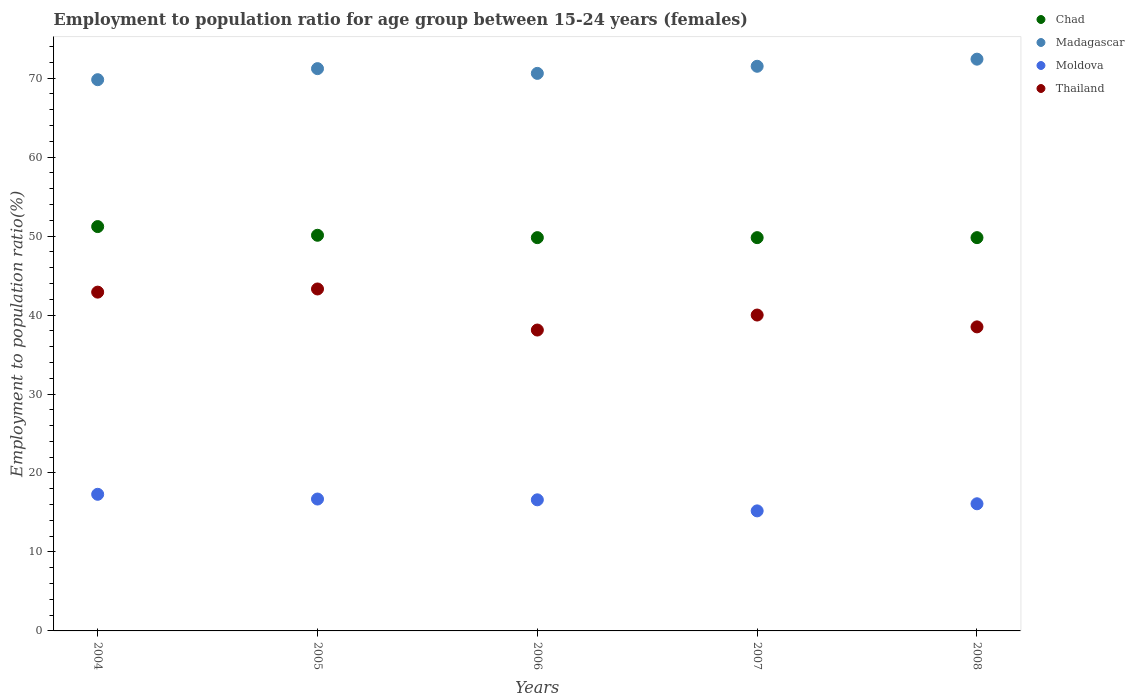How many different coloured dotlines are there?
Give a very brief answer. 4. Is the number of dotlines equal to the number of legend labels?
Offer a very short reply. Yes. What is the employment to population ratio in Thailand in 2006?
Your response must be concise. 38.1. Across all years, what is the maximum employment to population ratio in Madagascar?
Make the answer very short. 72.4. Across all years, what is the minimum employment to population ratio in Chad?
Provide a short and direct response. 49.8. In which year was the employment to population ratio in Moldova maximum?
Offer a terse response. 2004. What is the total employment to population ratio in Thailand in the graph?
Provide a succinct answer. 202.8. What is the difference between the employment to population ratio in Chad in 2005 and that in 2007?
Provide a succinct answer. 0.3. What is the difference between the employment to population ratio in Thailand in 2004 and the employment to population ratio in Chad in 2005?
Offer a very short reply. -7.2. What is the average employment to population ratio in Chad per year?
Your answer should be compact. 50.14. In the year 2004, what is the difference between the employment to population ratio in Chad and employment to population ratio in Moldova?
Your response must be concise. 33.9. What is the ratio of the employment to population ratio in Chad in 2006 to that in 2007?
Keep it short and to the point. 1. Is the employment to population ratio in Chad in 2005 less than that in 2007?
Your answer should be compact. No. What is the difference between the highest and the second highest employment to population ratio in Madagascar?
Keep it short and to the point. 0.9. What is the difference between the highest and the lowest employment to population ratio in Thailand?
Keep it short and to the point. 5.2. Is the sum of the employment to population ratio in Thailand in 2004 and 2007 greater than the maximum employment to population ratio in Moldova across all years?
Keep it short and to the point. Yes. Is the employment to population ratio in Chad strictly less than the employment to population ratio in Moldova over the years?
Ensure brevity in your answer.  No. How many years are there in the graph?
Give a very brief answer. 5. Are the values on the major ticks of Y-axis written in scientific E-notation?
Provide a short and direct response. No. Does the graph contain any zero values?
Make the answer very short. No. Does the graph contain grids?
Provide a succinct answer. No. Where does the legend appear in the graph?
Your answer should be compact. Top right. What is the title of the graph?
Your answer should be compact. Employment to population ratio for age group between 15-24 years (females). What is the Employment to population ratio(%) of Chad in 2004?
Keep it short and to the point. 51.2. What is the Employment to population ratio(%) in Madagascar in 2004?
Provide a succinct answer. 69.8. What is the Employment to population ratio(%) in Moldova in 2004?
Provide a succinct answer. 17.3. What is the Employment to population ratio(%) in Thailand in 2004?
Your answer should be compact. 42.9. What is the Employment to population ratio(%) in Chad in 2005?
Ensure brevity in your answer.  50.1. What is the Employment to population ratio(%) of Madagascar in 2005?
Provide a succinct answer. 71.2. What is the Employment to population ratio(%) of Moldova in 2005?
Provide a succinct answer. 16.7. What is the Employment to population ratio(%) in Thailand in 2005?
Give a very brief answer. 43.3. What is the Employment to population ratio(%) in Chad in 2006?
Give a very brief answer. 49.8. What is the Employment to population ratio(%) in Madagascar in 2006?
Give a very brief answer. 70.6. What is the Employment to population ratio(%) in Moldova in 2006?
Give a very brief answer. 16.6. What is the Employment to population ratio(%) in Thailand in 2006?
Offer a very short reply. 38.1. What is the Employment to population ratio(%) in Chad in 2007?
Ensure brevity in your answer.  49.8. What is the Employment to population ratio(%) in Madagascar in 2007?
Your answer should be compact. 71.5. What is the Employment to population ratio(%) of Moldova in 2007?
Give a very brief answer. 15.2. What is the Employment to population ratio(%) in Thailand in 2007?
Give a very brief answer. 40. What is the Employment to population ratio(%) of Chad in 2008?
Offer a terse response. 49.8. What is the Employment to population ratio(%) of Madagascar in 2008?
Provide a short and direct response. 72.4. What is the Employment to population ratio(%) in Moldova in 2008?
Make the answer very short. 16.1. What is the Employment to population ratio(%) of Thailand in 2008?
Offer a terse response. 38.5. Across all years, what is the maximum Employment to population ratio(%) of Chad?
Offer a terse response. 51.2. Across all years, what is the maximum Employment to population ratio(%) in Madagascar?
Offer a terse response. 72.4. Across all years, what is the maximum Employment to population ratio(%) of Moldova?
Provide a succinct answer. 17.3. Across all years, what is the maximum Employment to population ratio(%) in Thailand?
Ensure brevity in your answer.  43.3. Across all years, what is the minimum Employment to population ratio(%) of Chad?
Your response must be concise. 49.8. Across all years, what is the minimum Employment to population ratio(%) of Madagascar?
Your response must be concise. 69.8. Across all years, what is the minimum Employment to population ratio(%) in Moldova?
Keep it short and to the point. 15.2. Across all years, what is the minimum Employment to population ratio(%) of Thailand?
Keep it short and to the point. 38.1. What is the total Employment to population ratio(%) of Chad in the graph?
Give a very brief answer. 250.7. What is the total Employment to population ratio(%) of Madagascar in the graph?
Keep it short and to the point. 355.5. What is the total Employment to population ratio(%) in Moldova in the graph?
Your answer should be compact. 81.9. What is the total Employment to population ratio(%) of Thailand in the graph?
Your response must be concise. 202.8. What is the difference between the Employment to population ratio(%) of Chad in 2004 and that in 2005?
Offer a terse response. 1.1. What is the difference between the Employment to population ratio(%) of Madagascar in 2004 and that in 2005?
Make the answer very short. -1.4. What is the difference between the Employment to population ratio(%) in Moldova in 2004 and that in 2005?
Your answer should be compact. 0.6. What is the difference between the Employment to population ratio(%) in Thailand in 2004 and that in 2005?
Your answer should be very brief. -0.4. What is the difference between the Employment to population ratio(%) in Chad in 2004 and that in 2006?
Give a very brief answer. 1.4. What is the difference between the Employment to population ratio(%) of Madagascar in 2004 and that in 2006?
Keep it short and to the point. -0.8. What is the difference between the Employment to population ratio(%) in Moldova in 2004 and that in 2006?
Your answer should be very brief. 0.7. What is the difference between the Employment to population ratio(%) in Chad in 2004 and that in 2007?
Give a very brief answer. 1.4. What is the difference between the Employment to population ratio(%) of Moldova in 2004 and that in 2007?
Offer a terse response. 2.1. What is the difference between the Employment to population ratio(%) of Thailand in 2004 and that in 2007?
Offer a very short reply. 2.9. What is the difference between the Employment to population ratio(%) of Chad in 2004 and that in 2008?
Provide a succinct answer. 1.4. What is the difference between the Employment to population ratio(%) of Thailand in 2004 and that in 2008?
Make the answer very short. 4.4. What is the difference between the Employment to population ratio(%) in Madagascar in 2005 and that in 2006?
Make the answer very short. 0.6. What is the difference between the Employment to population ratio(%) in Thailand in 2005 and that in 2006?
Make the answer very short. 5.2. What is the difference between the Employment to population ratio(%) in Moldova in 2005 and that in 2007?
Your response must be concise. 1.5. What is the difference between the Employment to population ratio(%) of Thailand in 2005 and that in 2007?
Provide a short and direct response. 3.3. What is the difference between the Employment to population ratio(%) in Chad in 2005 and that in 2008?
Ensure brevity in your answer.  0.3. What is the difference between the Employment to population ratio(%) of Moldova in 2005 and that in 2008?
Make the answer very short. 0.6. What is the difference between the Employment to population ratio(%) in Chad in 2006 and that in 2007?
Give a very brief answer. 0. What is the difference between the Employment to population ratio(%) in Madagascar in 2006 and that in 2007?
Your answer should be very brief. -0.9. What is the difference between the Employment to population ratio(%) in Thailand in 2006 and that in 2007?
Provide a succinct answer. -1.9. What is the difference between the Employment to population ratio(%) of Chad in 2006 and that in 2008?
Provide a succinct answer. 0. What is the difference between the Employment to population ratio(%) of Madagascar in 2006 and that in 2008?
Offer a very short reply. -1.8. What is the difference between the Employment to population ratio(%) in Moldova in 2006 and that in 2008?
Offer a terse response. 0.5. What is the difference between the Employment to population ratio(%) in Chad in 2007 and that in 2008?
Give a very brief answer. 0. What is the difference between the Employment to population ratio(%) in Madagascar in 2007 and that in 2008?
Your answer should be very brief. -0.9. What is the difference between the Employment to population ratio(%) of Moldova in 2007 and that in 2008?
Make the answer very short. -0.9. What is the difference between the Employment to population ratio(%) in Chad in 2004 and the Employment to population ratio(%) in Moldova in 2005?
Keep it short and to the point. 34.5. What is the difference between the Employment to population ratio(%) of Madagascar in 2004 and the Employment to population ratio(%) of Moldova in 2005?
Your response must be concise. 53.1. What is the difference between the Employment to population ratio(%) in Moldova in 2004 and the Employment to population ratio(%) in Thailand in 2005?
Your answer should be very brief. -26. What is the difference between the Employment to population ratio(%) in Chad in 2004 and the Employment to population ratio(%) in Madagascar in 2006?
Keep it short and to the point. -19.4. What is the difference between the Employment to population ratio(%) in Chad in 2004 and the Employment to population ratio(%) in Moldova in 2006?
Offer a terse response. 34.6. What is the difference between the Employment to population ratio(%) of Madagascar in 2004 and the Employment to population ratio(%) of Moldova in 2006?
Offer a terse response. 53.2. What is the difference between the Employment to population ratio(%) of Madagascar in 2004 and the Employment to population ratio(%) of Thailand in 2006?
Keep it short and to the point. 31.7. What is the difference between the Employment to population ratio(%) of Moldova in 2004 and the Employment to population ratio(%) of Thailand in 2006?
Keep it short and to the point. -20.8. What is the difference between the Employment to population ratio(%) in Chad in 2004 and the Employment to population ratio(%) in Madagascar in 2007?
Offer a terse response. -20.3. What is the difference between the Employment to population ratio(%) of Chad in 2004 and the Employment to population ratio(%) of Moldova in 2007?
Make the answer very short. 36. What is the difference between the Employment to population ratio(%) of Chad in 2004 and the Employment to population ratio(%) of Thailand in 2007?
Offer a terse response. 11.2. What is the difference between the Employment to population ratio(%) of Madagascar in 2004 and the Employment to population ratio(%) of Moldova in 2007?
Ensure brevity in your answer.  54.6. What is the difference between the Employment to population ratio(%) of Madagascar in 2004 and the Employment to population ratio(%) of Thailand in 2007?
Offer a terse response. 29.8. What is the difference between the Employment to population ratio(%) in Moldova in 2004 and the Employment to population ratio(%) in Thailand in 2007?
Your answer should be very brief. -22.7. What is the difference between the Employment to population ratio(%) in Chad in 2004 and the Employment to population ratio(%) in Madagascar in 2008?
Your response must be concise. -21.2. What is the difference between the Employment to population ratio(%) of Chad in 2004 and the Employment to population ratio(%) of Moldova in 2008?
Give a very brief answer. 35.1. What is the difference between the Employment to population ratio(%) of Madagascar in 2004 and the Employment to population ratio(%) of Moldova in 2008?
Your answer should be compact. 53.7. What is the difference between the Employment to population ratio(%) of Madagascar in 2004 and the Employment to population ratio(%) of Thailand in 2008?
Make the answer very short. 31.3. What is the difference between the Employment to population ratio(%) in Moldova in 2004 and the Employment to population ratio(%) in Thailand in 2008?
Give a very brief answer. -21.2. What is the difference between the Employment to population ratio(%) in Chad in 2005 and the Employment to population ratio(%) in Madagascar in 2006?
Offer a terse response. -20.5. What is the difference between the Employment to population ratio(%) in Chad in 2005 and the Employment to population ratio(%) in Moldova in 2006?
Make the answer very short. 33.5. What is the difference between the Employment to population ratio(%) of Madagascar in 2005 and the Employment to population ratio(%) of Moldova in 2006?
Your response must be concise. 54.6. What is the difference between the Employment to population ratio(%) of Madagascar in 2005 and the Employment to population ratio(%) of Thailand in 2006?
Offer a very short reply. 33.1. What is the difference between the Employment to population ratio(%) in Moldova in 2005 and the Employment to population ratio(%) in Thailand in 2006?
Provide a succinct answer. -21.4. What is the difference between the Employment to population ratio(%) in Chad in 2005 and the Employment to population ratio(%) in Madagascar in 2007?
Offer a very short reply. -21.4. What is the difference between the Employment to population ratio(%) of Chad in 2005 and the Employment to population ratio(%) of Moldova in 2007?
Ensure brevity in your answer.  34.9. What is the difference between the Employment to population ratio(%) of Chad in 2005 and the Employment to population ratio(%) of Thailand in 2007?
Make the answer very short. 10.1. What is the difference between the Employment to population ratio(%) of Madagascar in 2005 and the Employment to population ratio(%) of Thailand in 2007?
Your answer should be compact. 31.2. What is the difference between the Employment to population ratio(%) in Moldova in 2005 and the Employment to population ratio(%) in Thailand in 2007?
Your answer should be compact. -23.3. What is the difference between the Employment to population ratio(%) of Chad in 2005 and the Employment to population ratio(%) of Madagascar in 2008?
Your answer should be very brief. -22.3. What is the difference between the Employment to population ratio(%) of Chad in 2005 and the Employment to population ratio(%) of Moldova in 2008?
Keep it short and to the point. 34. What is the difference between the Employment to population ratio(%) of Chad in 2005 and the Employment to population ratio(%) of Thailand in 2008?
Make the answer very short. 11.6. What is the difference between the Employment to population ratio(%) in Madagascar in 2005 and the Employment to population ratio(%) in Moldova in 2008?
Give a very brief answer. 55.1. What is the difference between the Employment to population ratio(%) in Madagascar in 2005 and the Employment to population ratio(%) in Thailand in 2008?
Make the answer very short. 32.7. What is the difference between the Employment to population ratio(%) in Moldova in 2005 and the Employment to population ratio(%) in Thailand in 2008?
Provide a short and direct response. -21.8. What is the difference between the Employment to population ratio(%) of Chad in 2006 and the Employment to population ratio(%) of Madagascar in 2007?
Ensure brevity in your answer.  -21.7. What is the difference between the Employment to population ratio(%) of Chad in 2006 and the Employment to population ratio(%) of Moldova in 2007?
Keep it short and to the point. 34.6. What is the difference between the Employment to population ratio(%) of Chad in 2006 and the Employment to population ratio(%) of Thailand in 2007?
Provide a short and direct response. 9.8. What is the difference between the Employment to population ratio(%) in Madagascar in 2006 and the Employment to population ratio(%) in Moldova in 2007?
Offer a terse response. 55.4. What is the difference between the Employment to population ratio(%) of Madagascar in 2006 and the Employment to population ratio(%) of Thailand in 2007?
Give a very brief answer. 30.6. What is the difference between the Employment to population ratio(%) in Moldova in 2006 and the Employment to population ratio(%) in Thailand in 2007?
Ensure brevity in your answer.  -23.4. What is the difference between the Employment to population ratio(%) of Chad in 2006 and the Employment to population ratio(%) of Madagascar in 2008?
Provide a short and direct response. -22.6. What is the difference between the Employment to population ratio(%) in Chad in 2006 and the Employment to population ratio(%) in Moldova in 2008?
Provide a short and direct response. 33.7. What is the difference between the Employment to population ratio(%) of Madagascar in 2006 and the Employment to population ratio(%) of Moldova in 2008?
Ensure brevity in your answer.  54.5. What is the difference between the Employment to population ratio(%) in Madagascar in 2006 and the Employment to population ratio(%) in Thailand in 2008?
Your answer should be compact. 32.1. What is the difference between the Employment to population ratio(%) of Moldova in 2006 and the Employment to population ratio(%) of Thailand in 2008?
Keep it short and to the point. -21.9. What is the difference between the Employment to population ratio(%) in Chad in 2007 and the Employment to population ratio(%) in Madagascar in 2008?
Offer a very short reply. -22.6. What is the difference between the Employment to population ratio(%) in Chad in 2007 and the Employment to population ratio(%) in Moldova in 2008?
Make the answer very short. 33.7. What is the difference between the Employment to population ratio(%) in Madagascar in 2007 and the Employment to population ratio(%) in Moldova in 2008?
Provide a succinct answer. 55.4. What is the difference between the Employment to population ratio(%) in Madagascar in 2007 and the Employment to population ratio(%) in Thailand in 2008?
Your answer should be very brief. 33. What is the difference between the Employment to population ratio(%) in Moldova in 2007 and the Employment to population ratio(%) in Thailand in 2008?
Make the answer very short. -23.3. What is the average Employment to population ratio(%) of Chad per year?
Give a very brief answer. 50.14. What is the average Employment to population ratio(%) of Madagascar per year?
Your response must be concise. 71.1. What is the average Employment to population ratio(%) of Moldova per year?
Your answer should be compact. 16.38. What is the average Employment to population ratio(%) in Thailand per year?
Your response must be concise. 40.56. In the year 2004, what is the difference between the Employment to population ratio(%) of Chad and Employment to population ratio(%) of Madagascar?
Your answer should be very brief. -18.6. In the year 2004, what is the difference between the Employment to population ratio(%) in Chad and Employment to population ratio(%) in Moldova?
Your response must be concise. 33.9. In the year 2004, what is the difference between the Employment to population ratio(%) in Chad and Employment to population ratio(%) in Thailand?
Your response must be concise. 8.3. In the year 2004, what is the difference between the Employment to population ratio(%) in Madagascar and Employment to population ratio(%) in Moldova?
Ensure brevity in your answer.  52.5. In the year 2004, what is the difference between the Employment to population ratio(%) in Madagascar and Employment to population ratio(%) in Thailand?
Give a very brief answer. 26.9. In the year 2004, what is the difference between the Employment to population ratio(%) in Moldova and Employment to population ratio(%) in Thailand?
Provide a succinct answer. -25.6. In the year 2005, what is the difference between the Employment to population ratio(%) in Chad and Employment to population ratio(%) in Madagascar?
Your answer should be compact. -21.1. In the year 2005, what is the difference between the Employment to population ratio(%) of Chad and Employment to population ratio(%) of Moldova?
Your answer should be very brief. 33.4. In the year 2005, what is the difference between the Employment to population ratio(%) of Chad and Employment to population ratio(%) of Thailand?
Give a very brief answer. 6.8. In the year 2005, what is the difference between the Employment to population ratio(%) of Madagascar and Employment to population ratio(%) of Moldova?
Keep it short and to the point. 54.5. In the year 2005, what is the difference between the Employment to population ratio(%) of Madagascar and Employment to population ratio(%) of Thailand?
Give a very brief answer. 27.9. In the year 2005, what is the difference between the Employment to population ratio(%) in Moldova and Employment to population ratio(%) in Thailand?
Offer a terse response. -26.6. In the year 2006, what is the difference between the Employment to population ratio(%) in Chad and Employment to population ratio(%) in Madagascar?
Provide a succinct answer. -20.8. In the year 2006, what is the difference between the Employment to population ratio(%) of Chad and Employment to population ratio(%) of Moldova?
Keep it short and to the point. 33.2. In the year 2006, what is the difference between the Employment to population ratio(%) in Madagascar and Employment to population ratio(%) in Moldova?
Offer a very short reply. 54. In the year 2006, what is the difference between the Employment to population ratio(%) of Madagascar and Employment to population ratio(%) of Thailand?
Your response must be concise. 32.5. In the year 2006, what is the difference between the Employment to population ratio(%) of Moldova and Employment to population ratio(%) of Thailand?
Give a very brief answer. -21.5. In the year 2007, what is the difference between the Employment to population ratio(%) in Chad and Employment to population ratio(%) in Madagascar?
Your answer should be very brief. -21.7. In the year 2007, what is the difference between the Employment to population ratio(%) of Chad and Employment to population ratio(%) of Moldova?
Keep it short and to the point. 34.6. In the year 2007, what is the difference between the Employment to population ratio(%) in Chad and Employment to population ratio(%) in Thailand?
Your answer should be very brief. 9.8. In the year 2007, what is the difference between the Employment to population ratio(%) in Madagascar and Employment to population ratio(%) in Moldova?
Offer a terse response. 56.3. In the year 2007, what is the difference between the Employment to population ratio(%) in Madagascar and Employment to population ratio(%) in Thailand?
Provide a short and direct response. 31.5. In the year 2007, what is the difference between the Employment to population ratio(%) in Moldova and Employment to population ratio(%) in Thailand?
Give a very brief answer. -24.8. In the year 2008, what is the difference between the Employment to population ratio(%) of Chad and Employment to population ratio(%) of Madagascar?
Make the answer very short. -22.6. In the year 2008, what is the difference between the Employment to population ratio(%) of Chad and Employment to population ratio(%) of Moldova?
Give a very brief answer. 33.7. In the year 2008, what is the difference between the Employment to population ratio(%) of Madagascar and Employment to population ratio(%) of Moldova?
Your answer should be compact. 56.3. In the year 2008, what is the difference between the Employment to population ratio(%) in Madagascar and Employment to population ratio(%) in Thailand?
Make the answer very short. 33.9. In the year 2008, what is the difference between the Employment to population ratio(%) of Moldova and Employment to population ratio(%) of Thailand?
Provide a short and direct response. -22.4. What is the ratio of the Employment to population ratio(%) of Chad in 2004 to that in 2005?
Ensure brevity in your answer.  1.02. What is the ratio of the Employment to population ratio(%) in Madagascar in 2004 to that in 2005?
Your answer should be compact. 0.98. What is the ratio of the Employment to population ratio(%) of Moldova in 2004 to that in 2005?
Make the answer very short. 1.04. What is the ratio of the Employment to population ratio(%) of Thailand in 2004 to that in 2005?
Your response must be concise. 0.99. What is the ratio of the Employment to population ratio(%) of Chad in 2004 to that in 2006?
Give a very brief answer. 1.03. What is the ratio of the Employment to population ratio(%) of Madagascar in 2004 to that in 2006?
Offer a terse response. 0.99. What is the ratio of the Employment to population ratio(%) of Moldova in 2004 to that in 2006?
Provide a succinct answer. 1.04. What is the ratio of the Employment to population ratio(%) in Thailand in 2004 to that in 2006?
Keep it short and to the point. 1.13. What is the ratio of the Employment to population ratio(%) in Chad in 2004 to that in 2007?
Your response must be concise. 1.03. What is the ratio of the Employment to population ratio(%) of Madagascar in 2004 to that in 2007?
Make the answer very short. 0.98. What is the ratio of the Employment to population ratio(%) in Moldova in 2004 to that in 2007?
Offer a very short reply. 1.14. What is the ratio of the Employment to population ratio(%) in Thailand in 2004 to that in 2007?
Provide a succinct answer. 1.07. What is the ratio of the Employment to population ratio(%) in Chad in 2004 to that in 2008?
Ensure brevity in your answer.  1.03. What is the ratio of the Employment to population ratio(%) of Madagascar in 2004 to that in 2008?
Provide a short and direct response. 0.96. What is the ratio of the Employment to population ratio(%) of Moldova in 2004 to that in 2008?
Offer a very short reply. 1.07. What is the ratio of the Employment to population ratio(%) of Thailand in 2004 to that in 2008?
Offer a very short reply. 1.11. What is the ratio of the Employment to population ratio(%) in Chad in 2005 to that in 2006?
Your answer should be compact. 1.01. What is the ratio of the Employment to population ratio(%) in Madagascar in 2005 to that in 2006?
Ensure brevity in your answer.  1.01. What is the ratio of the Employment to population ratio(%) of Moldova in 2005 to that in 2006?
Your answer should be compact. 1.01. What is the ratio of the Employment to population ratio(%) in Thailand in 2005 to that in 2006?
Offer a terse response. 1.14. What is the ratio of the Employment to population ratio(%) in Moldova in 2005 to that in 2007?
Your response must be concise. 1.1. What is the ratio of the Employment to population ratio(%) of Thailand in 2005 to that in 2007?
Provide a short and direct response. 1.08. What is the ratio of the Employment to population ratio(%) in Chad in 2005 to that in 2008?
Give a very brief answer. 1.01. What is the ratio of the Employment to population ratio(%) of Madagascar in 2005 to that in 2008?
Your response must be concise. 0.98. What is the ratio of the Employment to population ratio(%) of Moldova in 2005 to that in 2008?
Provide a short and direct response. 1.04. What is the ratio of the Employment to population ratio(%) in Thailand in 2005 to that in 2008?
Your answer should be compact. 1.12. What is the ratio of the Employment to population ratio(%) of Chad in 2006 to that in 2007?
Provide a succinct answer. 1. What is the ratio of the Employment to population ratio(%) in Madagascar in 2006 to that in 2007?
Offer a very short reply. 0.99. What is the ratio of the Employment to population ratio(%) of Moldova in 2006 to that in 2007?
Your answer should be very brief. 1.09. What is the ratio of the Employment to population ratio(%) in Thailand in 2006 to that in 2007?
Offer a very short reply. 0.95. What is the ratio of the Employment to population ratio(%) of Chad in 2006 to that in 2008?
Provide a succinct answer. 1. What is the ratio of the Employment to population ratio(%) of Madagascar in 2006 to that in 2008?
Offer a terse response. 0.98. What is the ratio of the Employment to population ratio(%) in Moldova in 2006 to that in 2008?
Provide a short and direct response. 1.03. What is the ratio of the Employment to population ratio(%) of Madagascar in 2007 to that in 2008?
Provide a short and direct response. 0.99. What is the ratio of the Employment to population ratio(%) in Moldova in 2007 to that in 2008?
Give a very brief answer. 0.94. What is the ratio of the Employment to population ratio(%) of Thailand in 2007 to that in 2008?
Offer a terse response. 1.04. What is the difference between the highest and the second highest Employment to population ratio(%) of Chad?
Offer a very short reply. 1.1. What is the difference between the highest and the lowest Employment to population ratio(%) of Chad?
Make the answer very short. 1.4. What is the difference between the highest and the lowest Employment to population ratio(%) in Madagascar?
Your answer should be compact. 2.6. What is the difference between the highest and the lowest Employment to population ratio(%) of Thailand?
Provide a short and direct response. 5.2. 